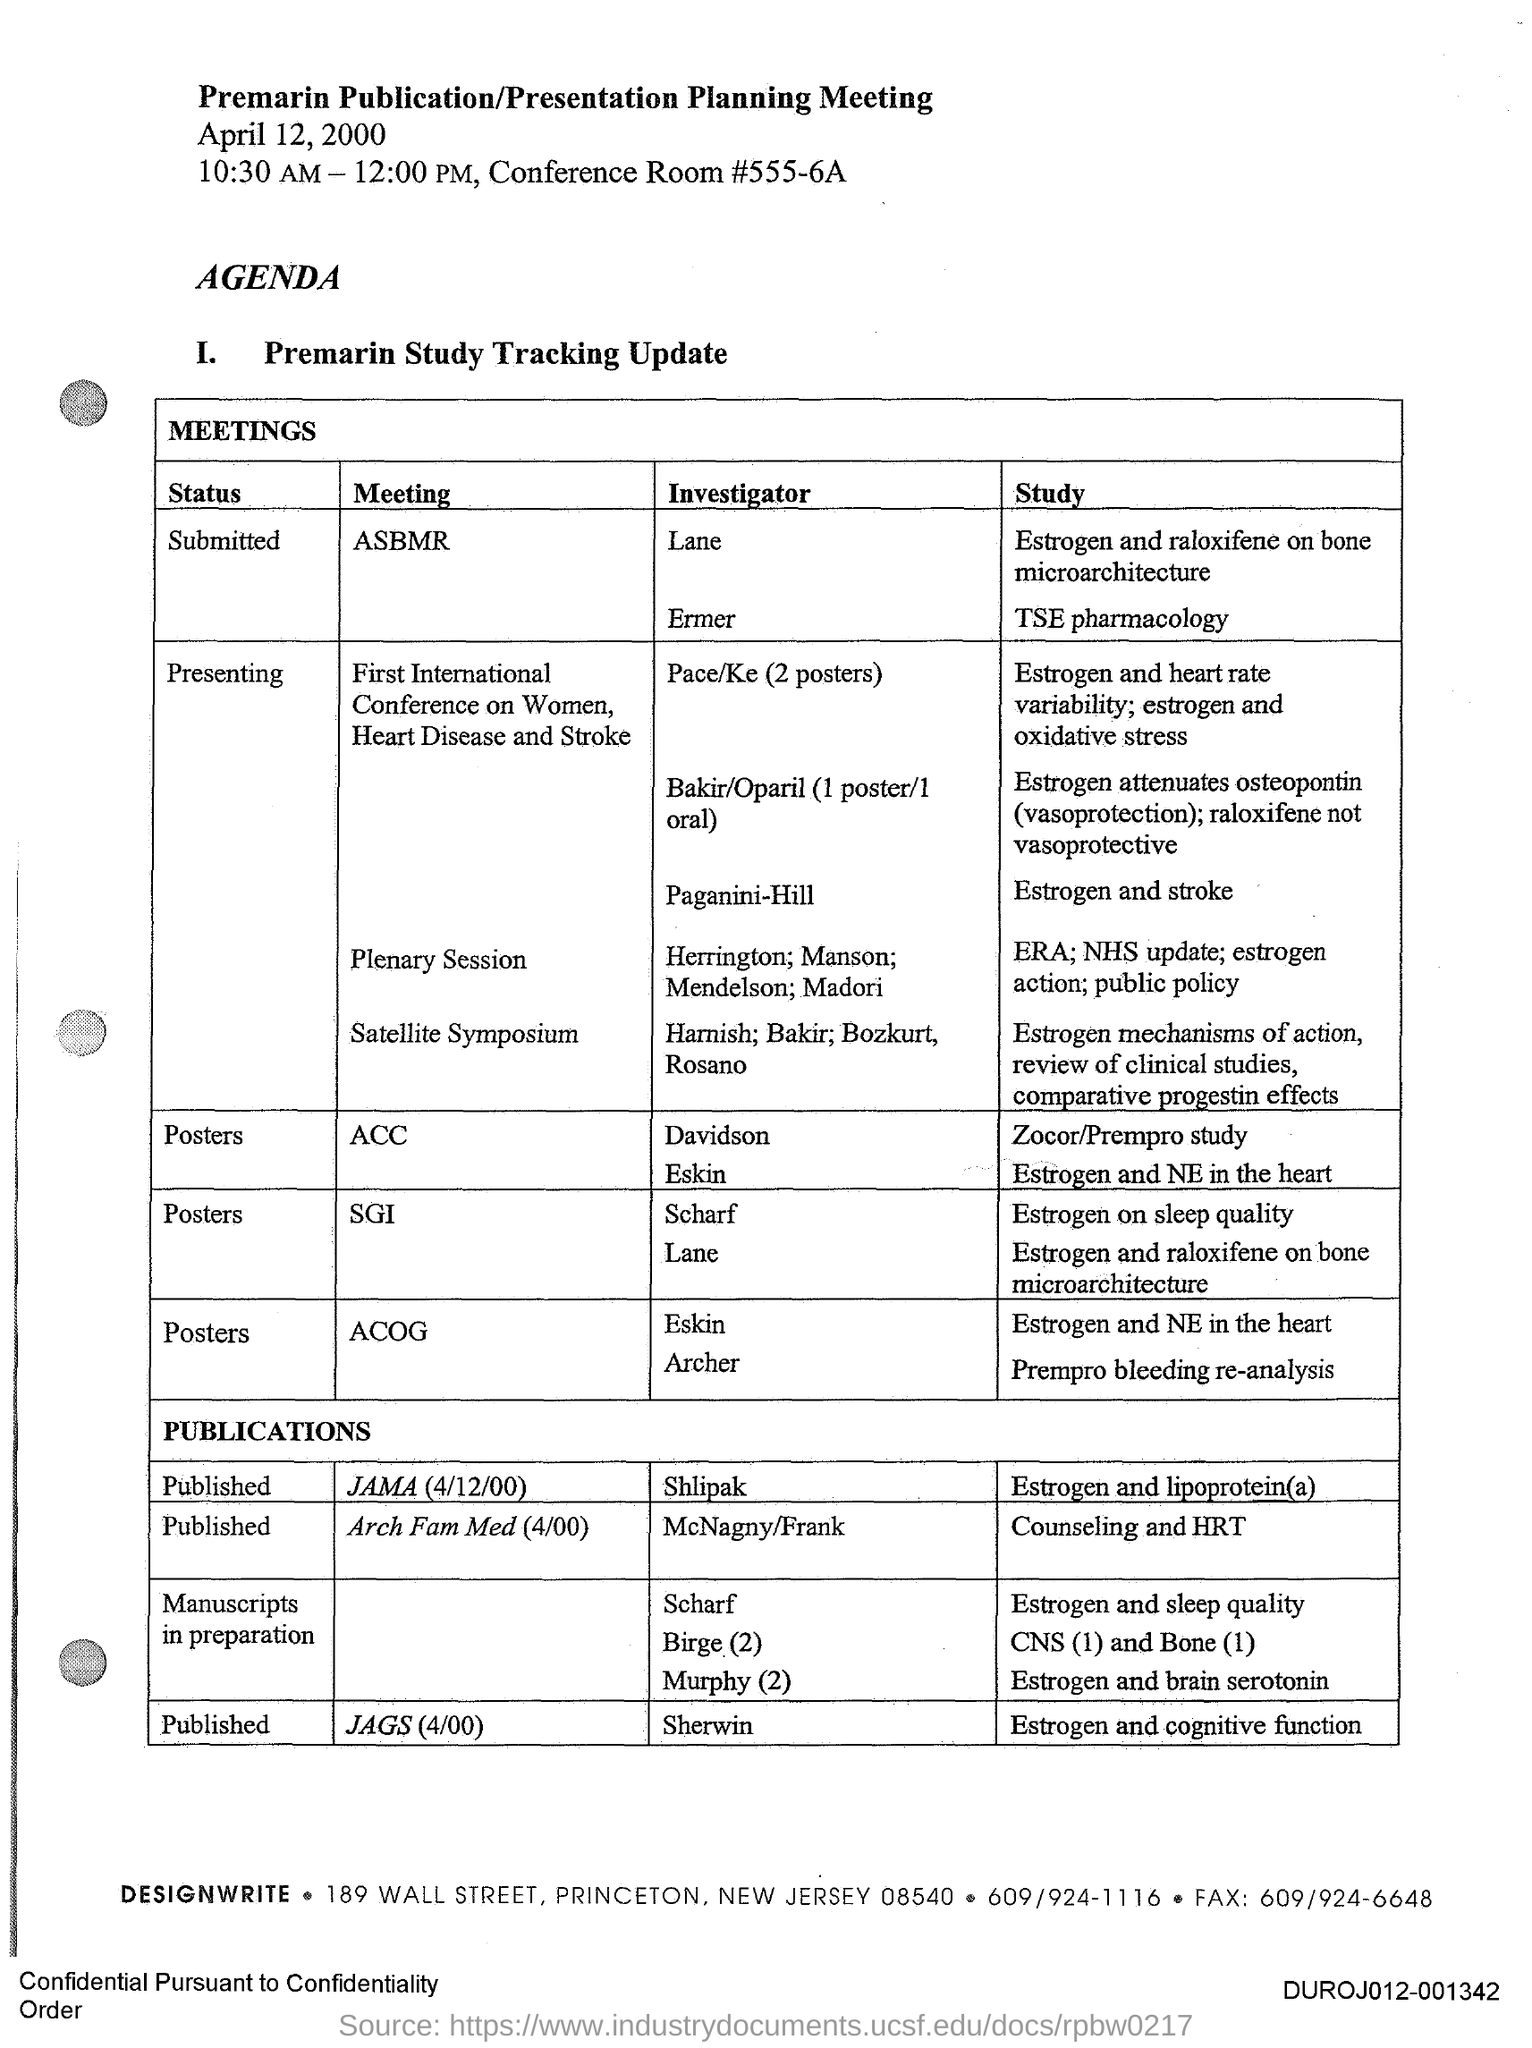What is the title of the document?
Your response must be concise. Premarin Publication/Presentation Planning Meeting. Who is the Investigator of the meeting publication JAMA (4/12/00)?
Your answer should be compact. Shlipak. Who is the Investigator of the meeting JAGS (4/00)?
Ensure brevity in your answer.  Sherwin. What is the status of the meeting "ASBMR"?
Offer a terse response. Submitted. What is the status of the meeting "ACC"?
Provide a succinct answer. Posters. 